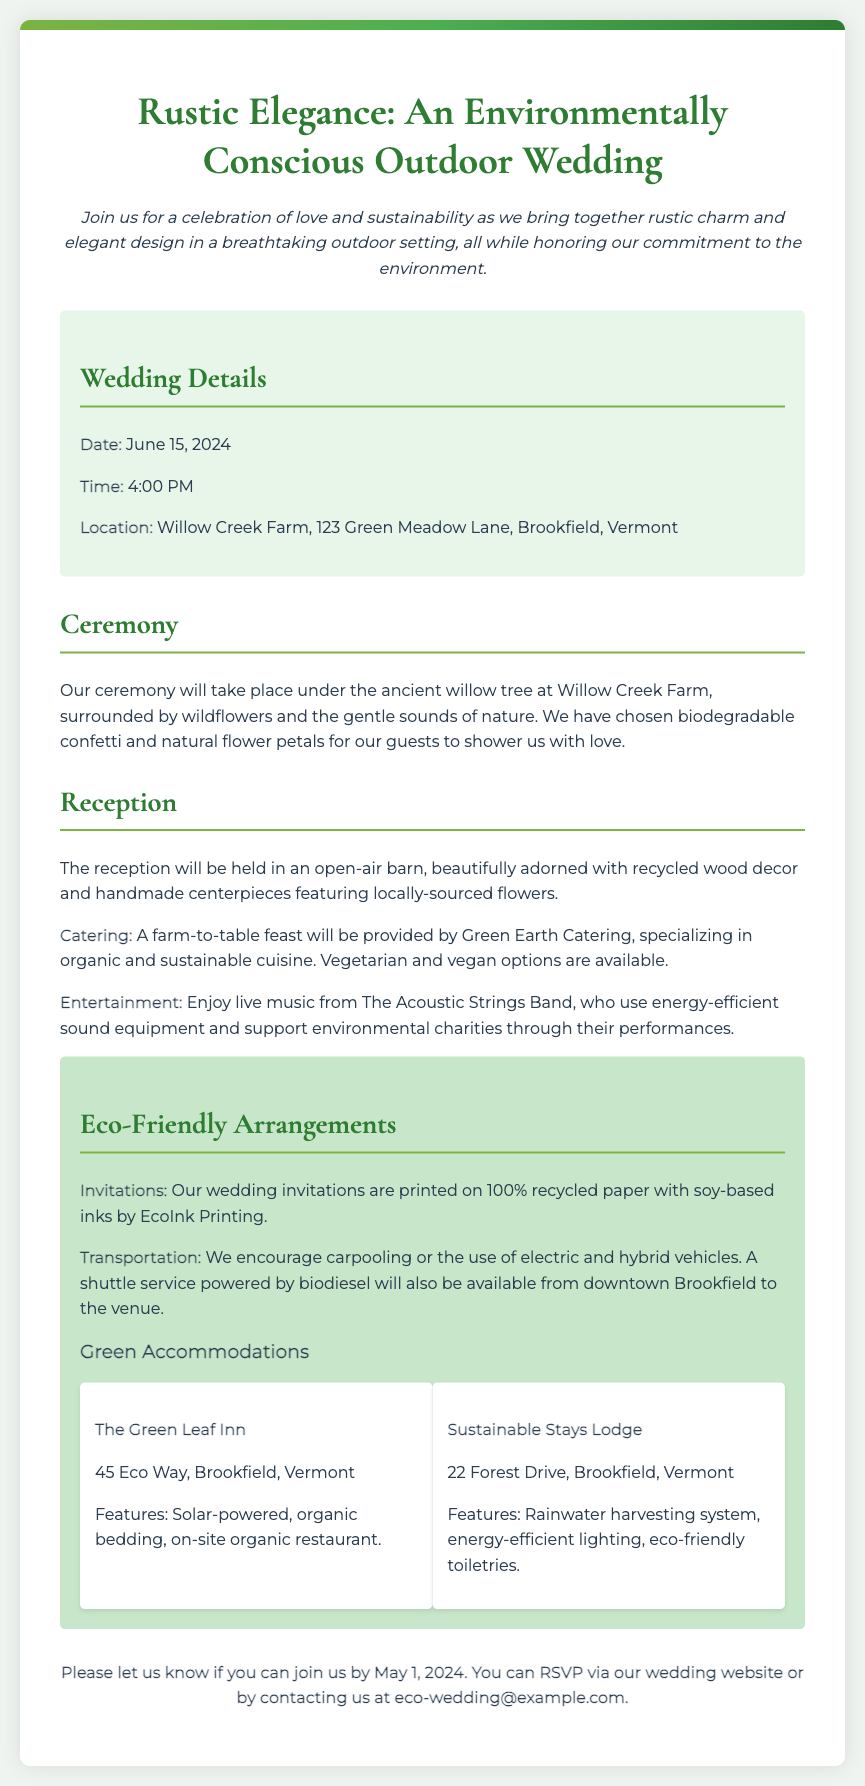what is the date of the wedding? The date of the wedding is specifically mentioned in the details section of the invitation.
Answer: June 15, 2024 what time does the ceremony start? The time is provided in the wedding details, indicating when the ceremony will begin.
Answer: 4:00 PM where is the wedding venue located? The location is specified in the details section of the invitation, providing the full address.
Answer: Willow Creek Farm, 123 Green Meadow Lane, Brookfield, Vermont what type of catering will be provided? The type of catering is highlighted in the reception section, specifying the catering style and offerings.
Answer: Farm-to-table feast what is a unique element of the ceremony? The ceremony description mentions a specific element that reflects the couple's commitment to sustainability.
Answer: Biodegradable confetti how are the invitations printed? The eco-friendly arrangements section describes how the invitations align with environmental consciousness.
Answer: 100% recycled paper what are the names of the hotels for accommodations? The accommodations section lists the names of two hotels available for guests.
Answer: The Green Leaf Inn and Sustainable Stays Lodge who will provide the live music? The entertainment section specifies the name of the band performing at the reception.
Answer: The Acoustic Strings Band what should guests do for transportation? The eco-friendly arrangements highlight how guests are encouraged to travel to the venue.
Answer: Carpooling or use electric vehicles 